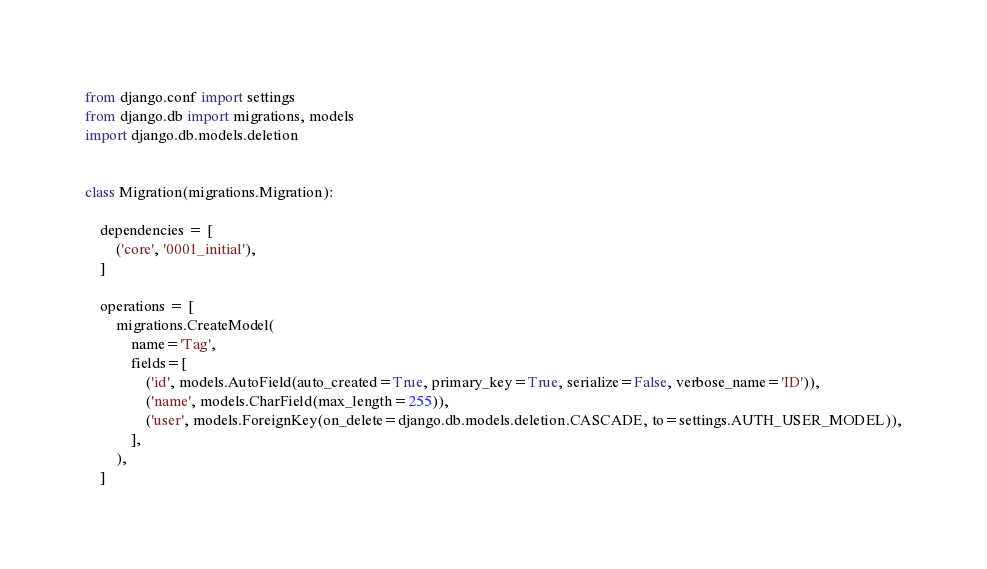<code> <loc_0><loc_0><loc_500><loc_500><_Python_>from django.conf import settings
from django.db import migrations, models
import django.db.models.deletion


class Migration(migrations.Migration):

    dependencies = [
        ('core', '0001_initial'),
    ]

    operations = [
        migrations.CreateModel(
            name='Tag',
            fields=[
                ('id', models.AutoField(auto_created=True, primary_key=True, serialize=False, verbose_name='ID')),
                ('name', models.CharField(max_length=255)),
                ('user', models.ForeignKey(on_delete=django.db.models.deletion.CASCADE, to=settings.AUTH_USER_MODEL)),
            ],
        ),
    ]
</code> 